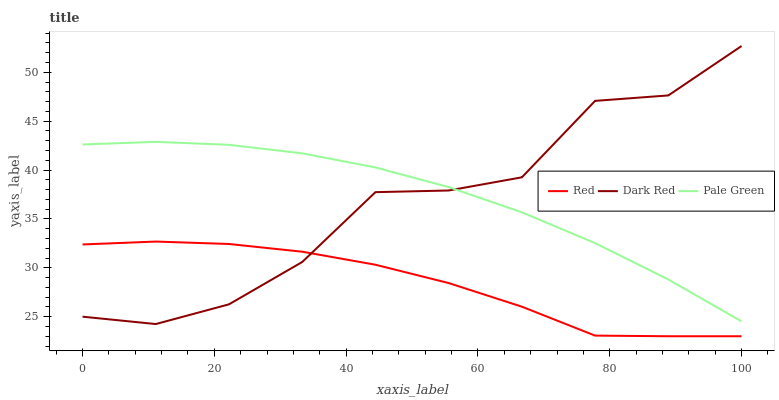Does Red have the minimum area under the curve?
Answer yes or no. Yes. Does Pale Green have the maximum area under the curve?
Answer yes or no. Yes. Does Pale Green have the minimum area under the curve?
Answer yes or no. No. Does Red have the maximum area under the curve?
Answer yes or no. No. Is Pale Green the smoothest?
Answer yes or no. Yes. Is Dark Red the roughest?
Answer yes or no. Yes. Is Red the smoothest?
Answer yes or no. No. Is Red the roughest?
Answer yes or no. No. Does Red have the lowest value?
Answer yes or no. Yes. Does Pale Green have the lowest value?
Answer yes or no. No. Does Dark Red have the highest value?
Answer yes or no. Yes. Does Pale Green have the highest value?
Answer yes or no. No. Is Red less than Pale Green?
Answer yes or no. Yes. Is Pale Green greater than Red?
Answer yes or no. Yes. Does Pale Green intersect Dark Red?
Answer yes or no. Yes. Is Pale Green less than Dark Red?
Answer yes or no. No. Is Pale Green greater than Dark Red?
Answer yes or no. No. Does Red intersect Pale Green?
Answer yes or no. No. 